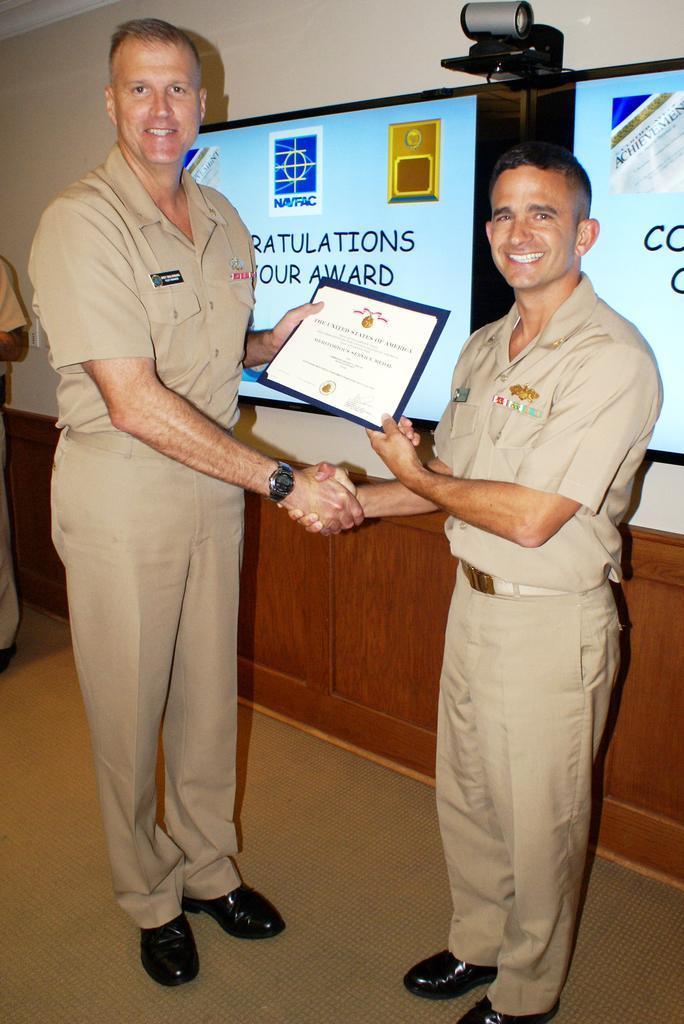Please provide a concise description of this image. In this image we can see persons standing on the floor and one of them is holding a certificate in his hands. In the background we can see cc camera and an advertisement. 